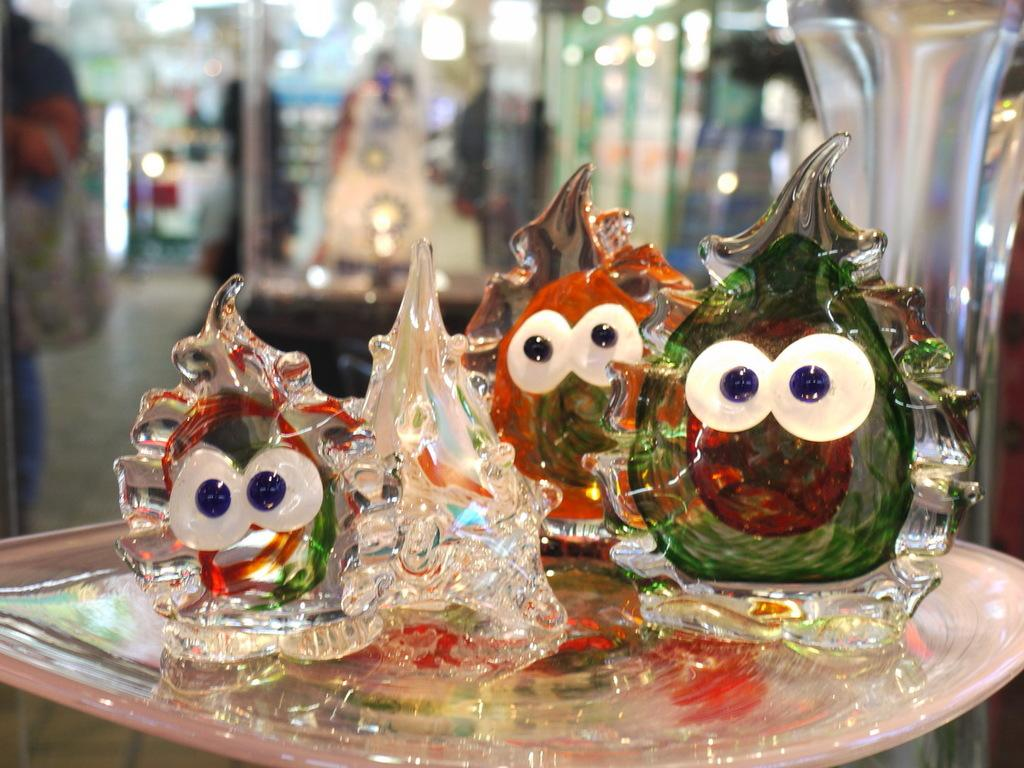What type of toys are in the image? There are glass toys in the image. Where are the glass toys located? The glass toys are in a plate. What color is the plate? The plate is white. Can you describe the background of the image? The background of the image is blurred. How many cables are connected to the glass toys in the image? There are no cables connected to the glass toys in the image, as they are toys made of glass. 